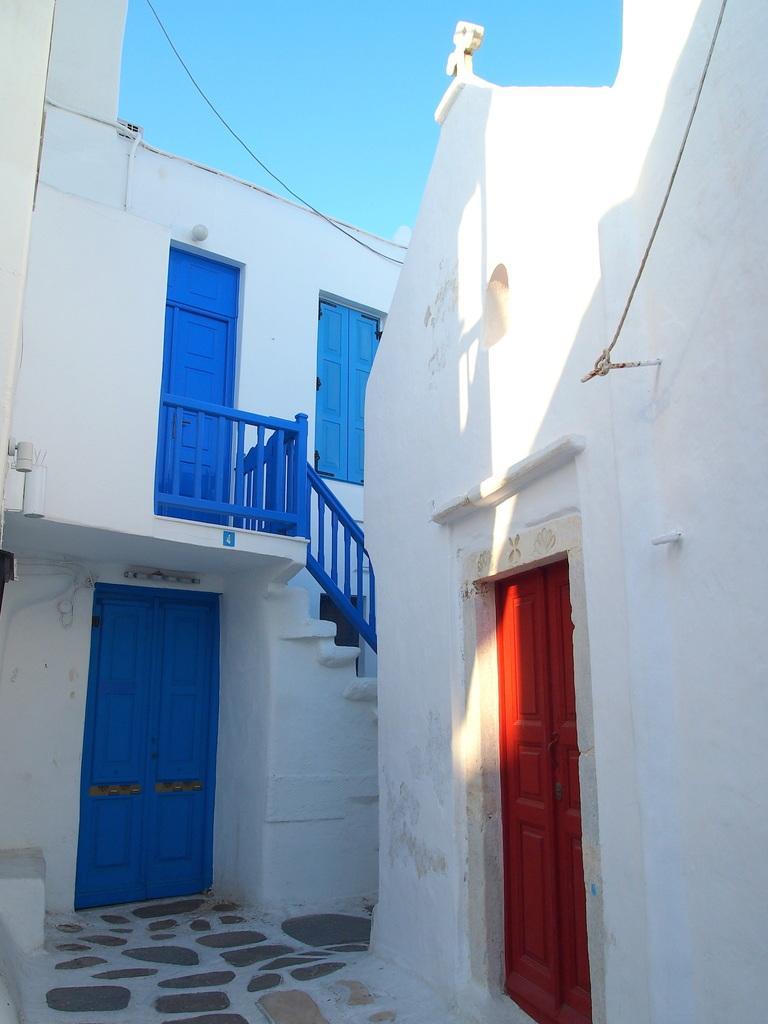In one or two sentences, can you explain what this image depicts? In this image, we can see buildings contains doors, staircase and window. There is a sky at the top of the image. 